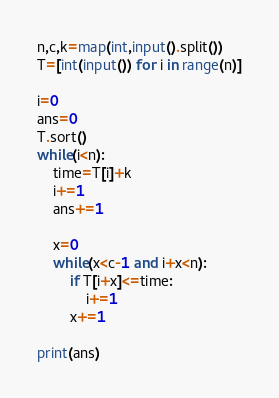<code> <loc_0><loc_0><loc_500><loc_500><_Python_>n,c,k=map(int,input().split())
T=[int(input()) for i in range(n)]

i=0
ans=0
T.sort()
while(i<n):
    time=T[i]+k
    i+=1
    ans+=1

    x=0
    while(x<c-1 and i+x<n):
        if T[i+x]<=time:
            i+=1
        x+=1

print(ans)</code> 